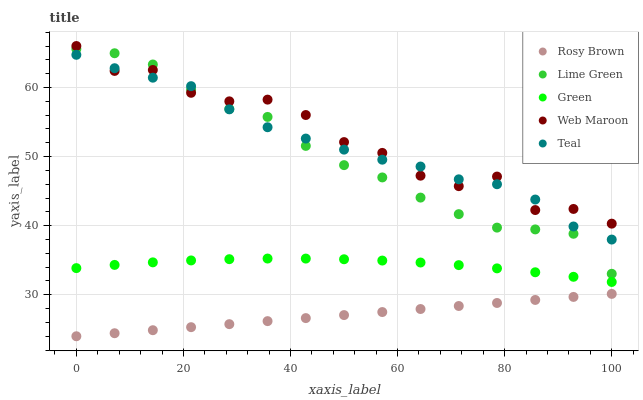Does Rosy Brown have the minimum area under the curve?
Answer yes or no. Yes. Does Web Maroon have the maximum area under the curve?
Answer yes or no. Yes. Does Lime Green have the minimum area under the curve?
Answer yes or no. No. Does Lime Green have the maximum area under the curve?
Answer yes or no. No. Is Rosy Brown the smoothest?
Answer yes or no. Yes. Is Web Maroon the roughest?
Answer yes or no. Yes. Is Lime Green the smoothest?
Answer yes or no. No. Is Lime Green the roughest?
Answer yes or no. No. Does Rosy Brown have the lowest value?
Answer yes or no. Yes. Does Lime Green have the lowest value?
Answer yes or no. No. Does Web Maroon have the highest value?
Answer yes or no. Yes. Does Lime Green have the highest value?
Answer yes or no. No. Is Rosy Brown less than Lime Green?
Answer yes or no. Yes. Is Green greater than Rosy Brown?
Answer yes or no. Yes. Does Teal intersect Web Maroon?
Answer yes or no. Yes. Is Teal less than Web Maroon?
Answer yes or no. No. Is Teal greater than Web Maroon?
Answer yes or no. No. Does Rosy Brown intersect Lime Green?
Answer yes or no. No. 